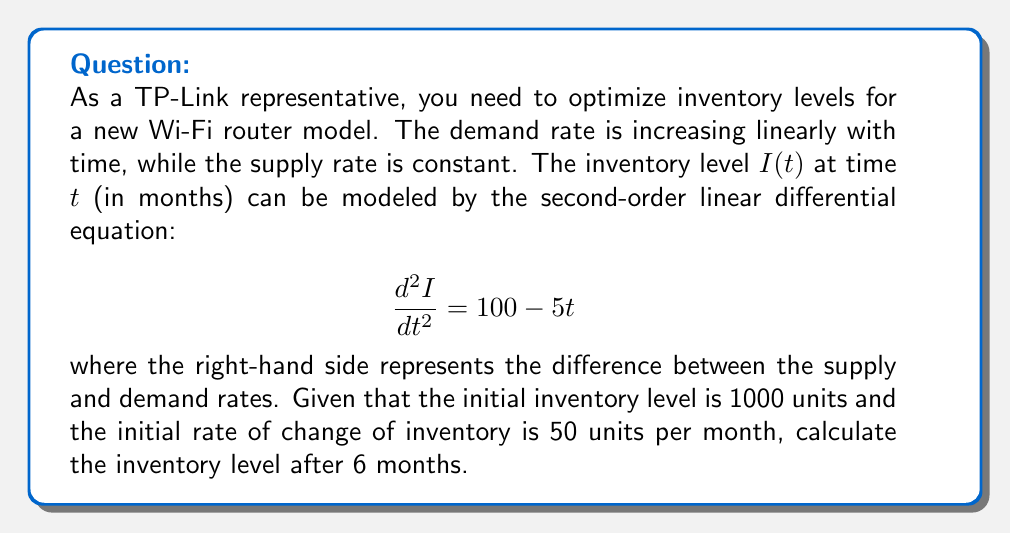Provide a solution to this math problem. To solve this problem, we need to follow these steps:

1) The given differential equation is:
   $$\frac{d^2I}{dt^2} = 100 - 5t$$

2) This is a non-homogeneous second-order linear differential equation. The general solution will be the sum of the complementary function and the particular integral.

3) The complementary function (solution to the homogeneous equation) is:
   $$I_c(t) = C_1 + C_2t$$
   where $C_1$ and $C_2$ are constants to be determined.

4) For the particular integral, we can use the method of undetermined coefficients. Let's assume a solution of the form:
   $$I_p(t) = at^2 + bt + c$$
   
   Substituting this into the original equation:
   $$\frac{d^2}{dt^2}(at^2 + bt + c) = 100 - 5t$$
   $$2a = 100 - 5t$$

   Equating coefficients:
   $2a = 100$, so $a = 50$
   $-5t = 0$, so $b = 0$
   
   The value of $c$ doesn't matter for the second derivative, so we can set $c = 0$.

   Therefore, the particular integral is:
   $$I_p(t) = 50t^2$$

5) The general solution is:
   $$I(t) = I_c(t) + I_p(t) = C_1 + C_2t + 50t^2$$

6) Now we use the initial conditions to find $C_1$ and $C_2$:
   At $t = 0$, $I(0) = 1000$, so:
   $$1000 = C_1$$

   At $t = 0$, $\frac{dI}{dt}(0) = 50$, so:
   $$50 = C_2 + 0$$

   Therefore, $C_1 = 1000$ and $C_2 = 50$

7) The complete solution is:
   $$I(t) = 1000 + 50t + 50t^2$$

8) To find the inventory level after 6 months, we substitute $t = 6$:
   $$I(6) = 1000 + 50(6) + 50(6^2) = 1000 + 300 + 1800 = 3100$$
Answer: The inventory level after 6 months will be 3100 units. 